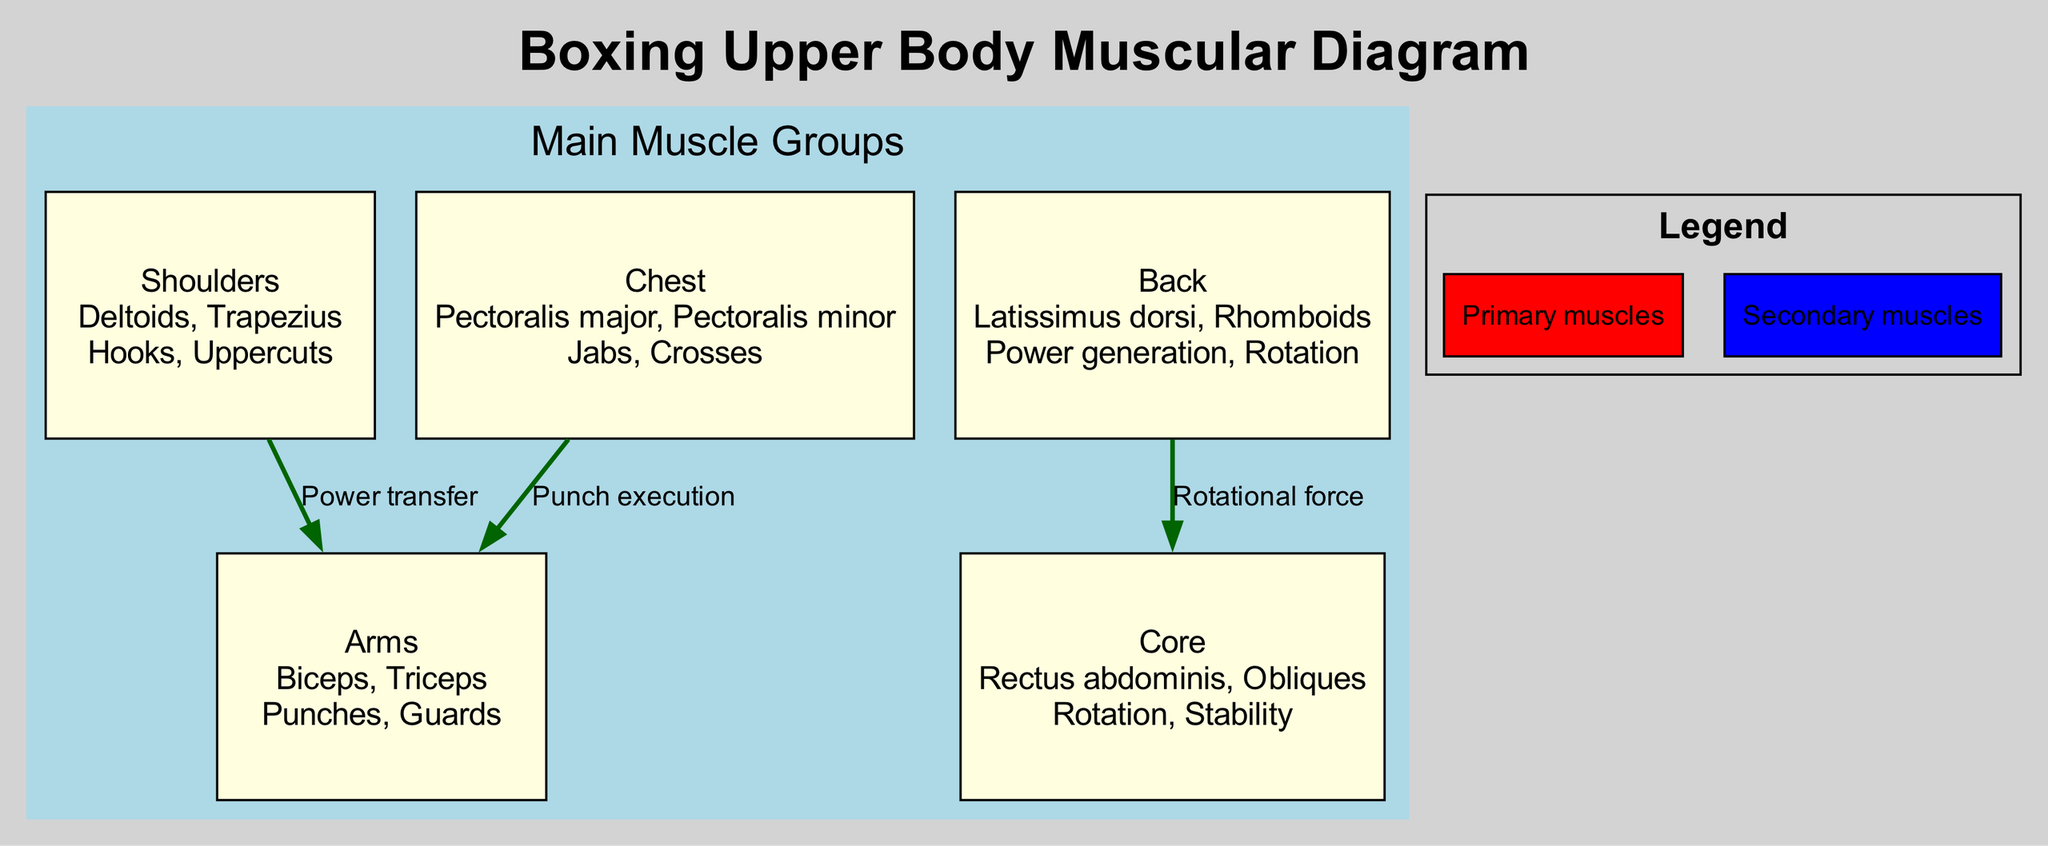What's the main boxing technique associated with the Chest? The main boxing technique associated with the Chest is "Jabs, Crosses," as listed in the diagram under the Chest component.
Answer: Jabs, Crosses How many main muscle groups are showcased in the diagram? The diagram showcases a total of five main muscle groups: Shoulders, Chest, Back, Arms, and Core.
Answer: 5 What is the primary muscle in the Shoulders group? The primary muscle in the Shoulders group is "Deltoids," which is mentioned along with Trapezius for that group in the diagram.
Answer: Deltoids Which muscle connects the Back to the Core? The muscle that connects the Back to the Core through the described "Rotational force" is "Latissimus dorsi," as it contributes to the overall movement dynamics outlined.
Answer: Latissimus dorsi What color represents the Primary muscles in the legend? The color that represents the Primary muscles in the legend is "Red."
Answer: Red What is the function of the connection between Shoulders and Arms? The function of the connection between Shoulders and Arms is "Power transfer," indicating how strength moves through these muscle groups during boxing actions.
Answer: Power transfer Which muscle in the Arms group is responsible for punch execution? The muscle responsible for punch execution in the Arms group is "Biceps," as it is crucial for lifting and striking.
Answer: Biceps How many connections are shown in the diagram? The diagram shows three connections illustrating how different muscle groups interact with one another.
Answer: 3 What is the boxing technique associated with the Core muscle group? The boxing technique associated with the Core muscle group is "Rotation, Stability," highlighting its role in maintaining posture and executing movements.
Answer: Rotation, Stability 